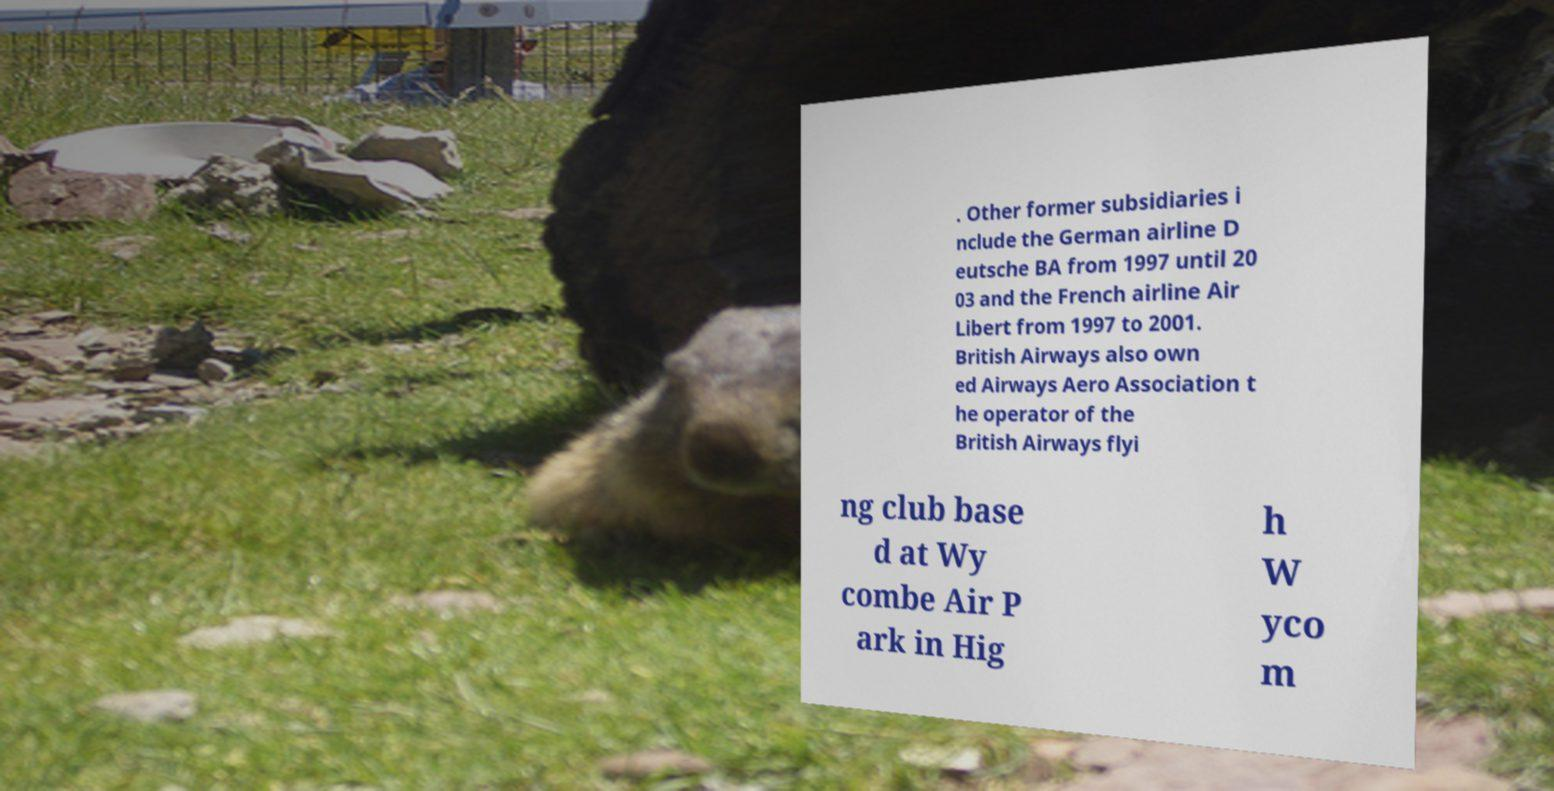For documentation purposes, I need the text within this image transcribed. Could you provide that? . Other former subsidiaries i nclude the German airline D eutsche BA from 1997 until 20 03 and the French airline Air Libert from 1997 to 2001. British Airways also own ed Airways Aero Association t he operator of the British Airways flyi ng club base d at Wy combe Air P ark in Hig h W yco m 